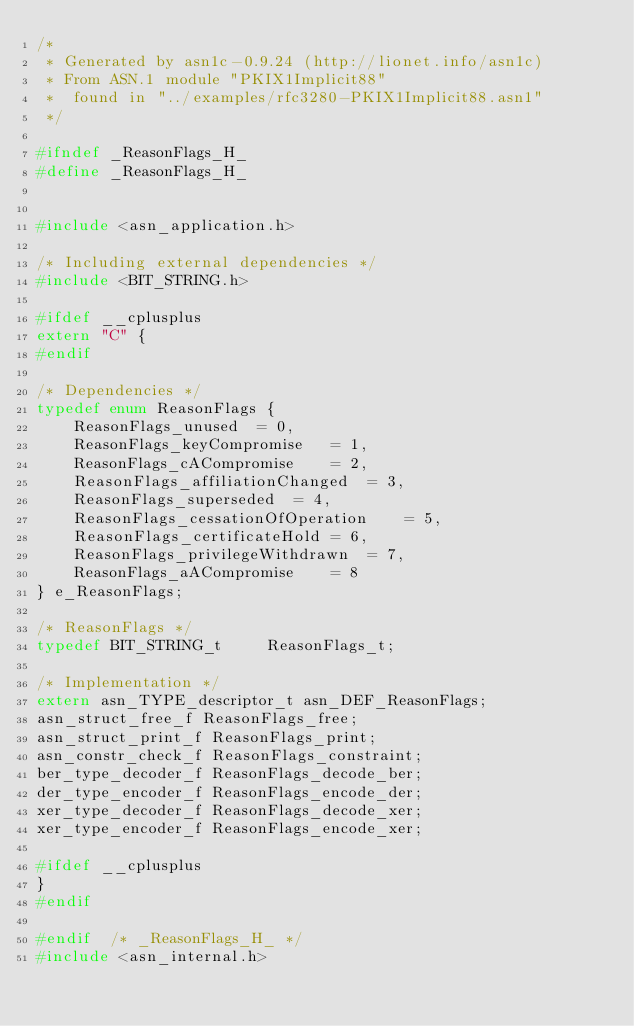<code> <loc_0><loc_0><loc_500><loc_500><_C_>/*
 * Generated by asn1c-0.9.24 (http://lionet.info/asn1c)
 * From ASN.1 module "PKIX1Implicit88"
 * 	found in "../examples/rfc3280-PKIX1Implicit88.asn1"
 */

#ifndef	_ReasonFlags_H_
#define	_ReasonFlags_H_


#include <asn_application.h>

/* Including external dependencies */
#include <BIT_STRING.h>

#ifdef __cplusplus
extern "C" {
#endif

/* Dependencies */
typedef enum ReasonFlags {
	ReasonFlags_unused	= 0,
	ReasonFlags_keyCompromise	= 1,
	ReasonFlags_cACompromise	= 2,
	ReasonFlags_affiliationChanged	= 3,
	ReasonFlags_superseded	= 4,
	ReasonFlags_cessationOfOperation	= 5,
	ReasonFlags_certificateHold	= 6,
	ReasonFlags_privilegeWithdrawn	= 7,
	ReasonFlags_aACompromise	= 8
} e_ReasonFlags;

/* ReasonFlags */
typedef BIT_STRING_t	 ReasonFlags_t;

/* Implementation */
extern asn_TYPE_descriptor_t asn_DEF_ReasonFlags;
asn_struct_free_f ReasonFlags_free;
asn_struct_print_f ReasonFlags_print;
asn_constr_check_f ReasonFlags_constraint;
ber_type_decoder_f ReasonFlags_decode_ber;
der_type_encoder_f ReasonFlags_encode_der;
xer_type_decoder_f ReasonFlags_decode_xer;
xer_type_encoder_f ReasonFlags_encode_xer;

#ifdef __cplusplus
}
#endif

#endif	/* _ReasonFlags_H_ */
#include <asn_internal.h>
</code> 